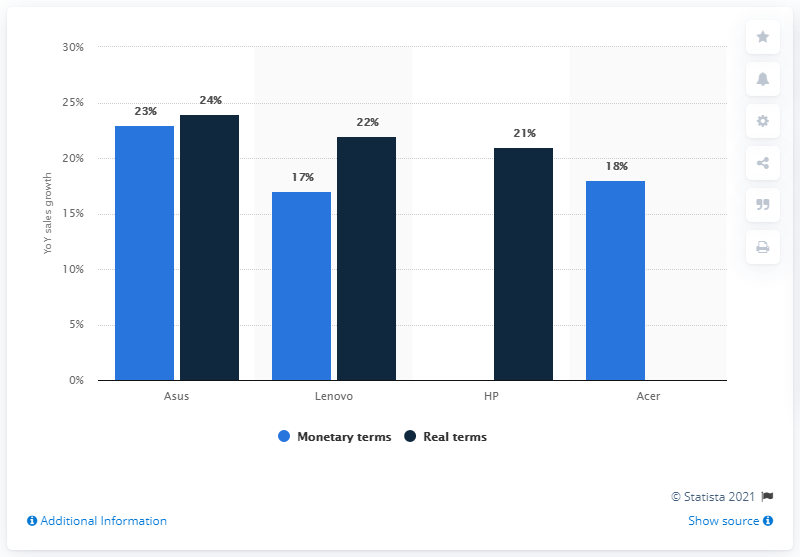Identify some key points in this picture. The average of all the dark blue bars is approximately 22.33. The chart shows a comparison of four companies. As per the data available in March 2020, Asus was the leading laptop brand in Russia. 